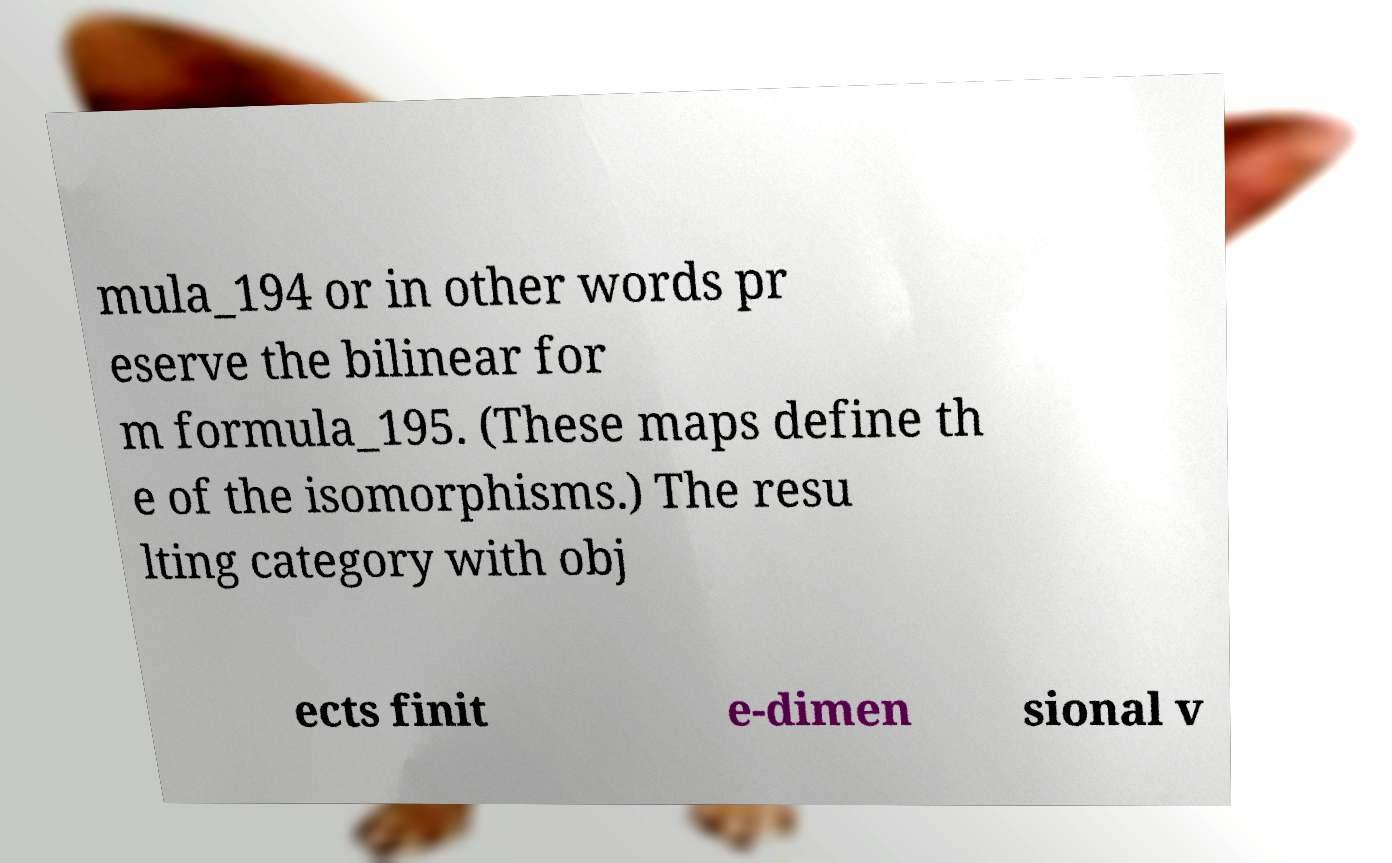There's text embedded in this image that I need extracted. Can you transcribe it verbatim? mula_194 or in other words pr eserve the bilinear for m formula_195. (These maps define th e of the isomorphisms.) The resu lting category with obj ects finit e-dimen sional v 